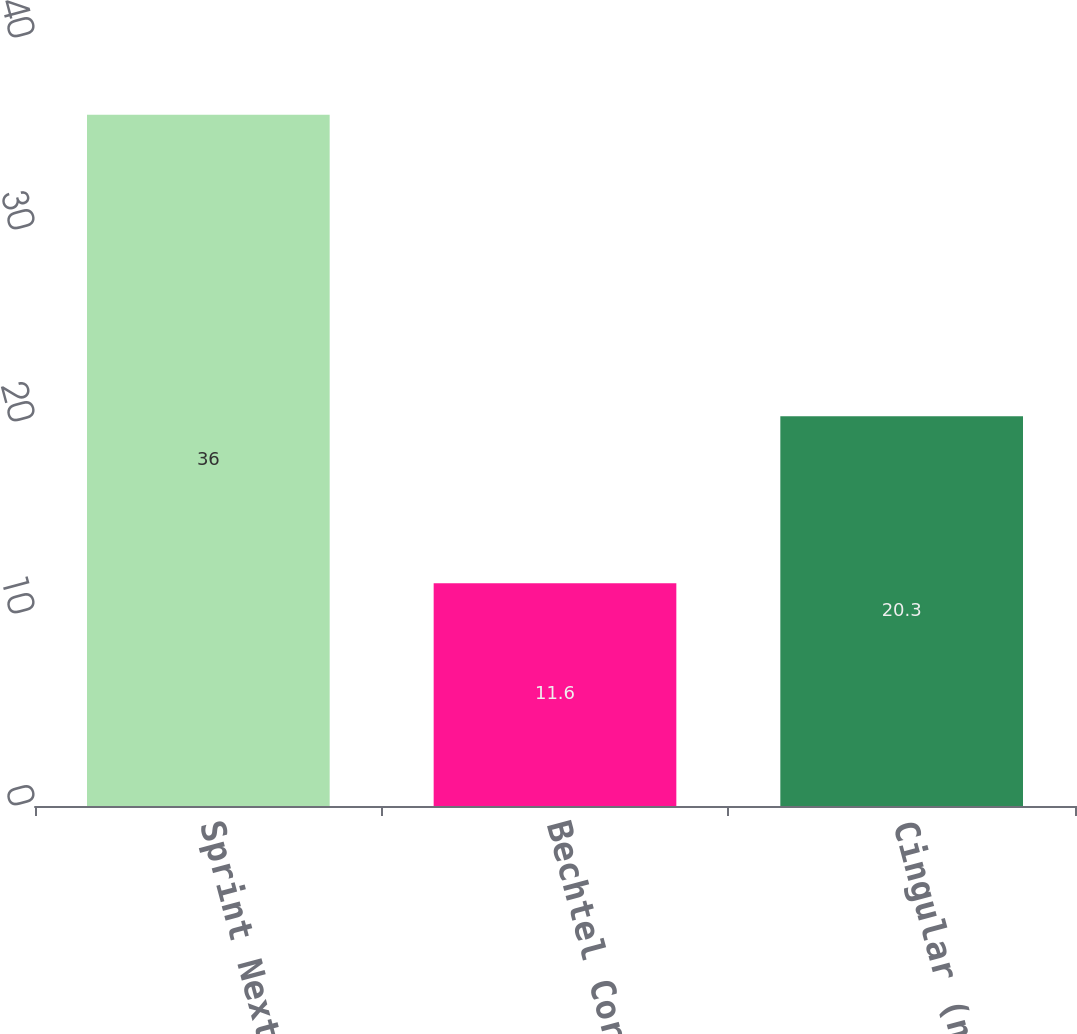<chart> <loc_0><loc_0><loc_500><loc_500><bar_chart><fcel>Sprint Nextel<fcel>Bechtel Corporation<fcel>Cingular (now AT&T)<nl><fcel>36<fcel>11.6<fcel>20.3<nl></chart> 